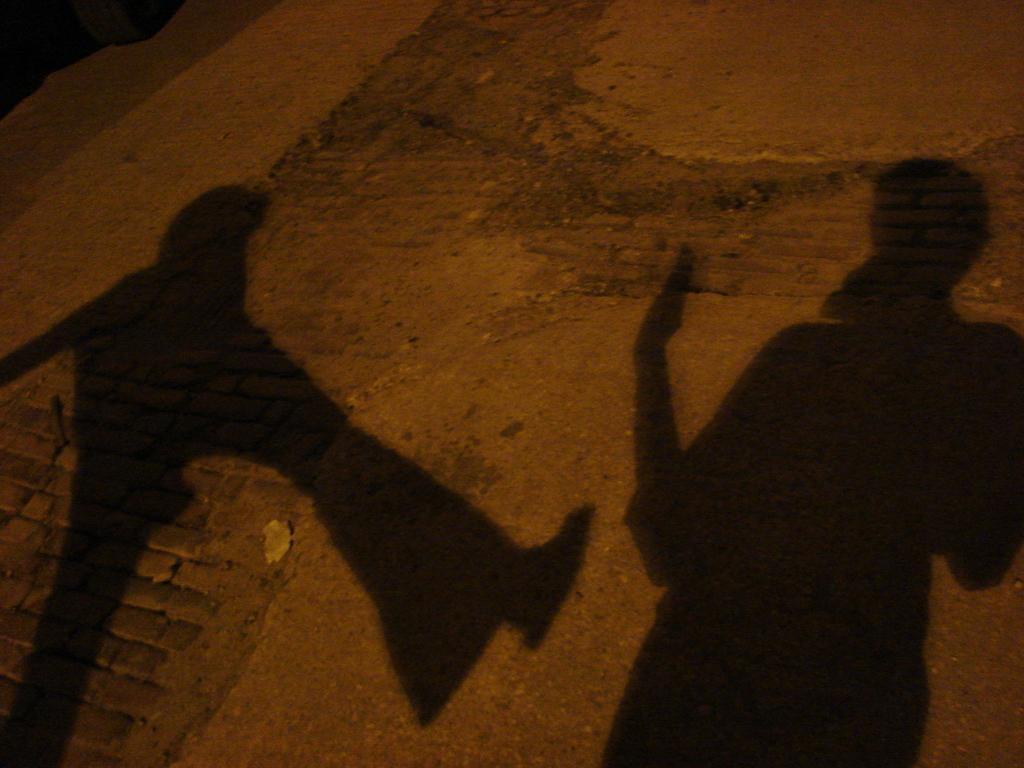How would you summarize this image in a sentence or two? In this image we can see shadows of two persons on the ground. 